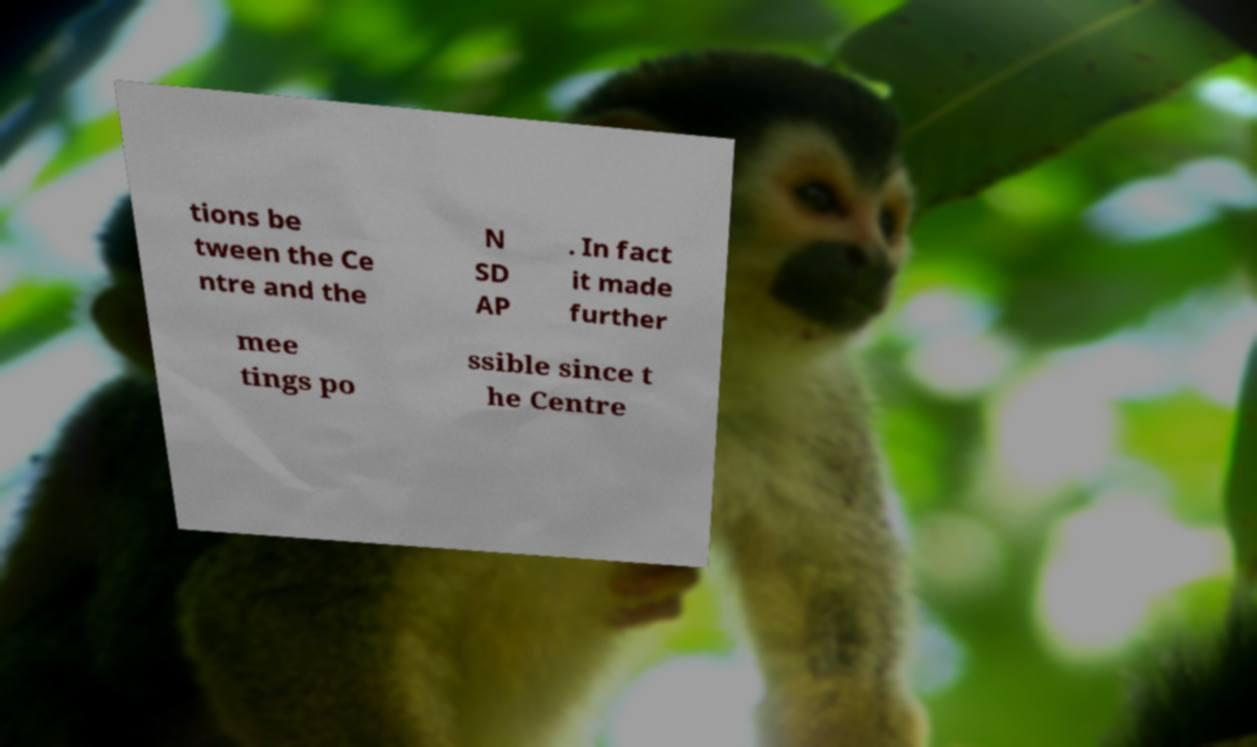Could you assist in decoding the text presented in this image and type it out clearly? tions be tween the Ce ntre and the N SD AP . In fact it made further mee tings po ssible since t he Centre 